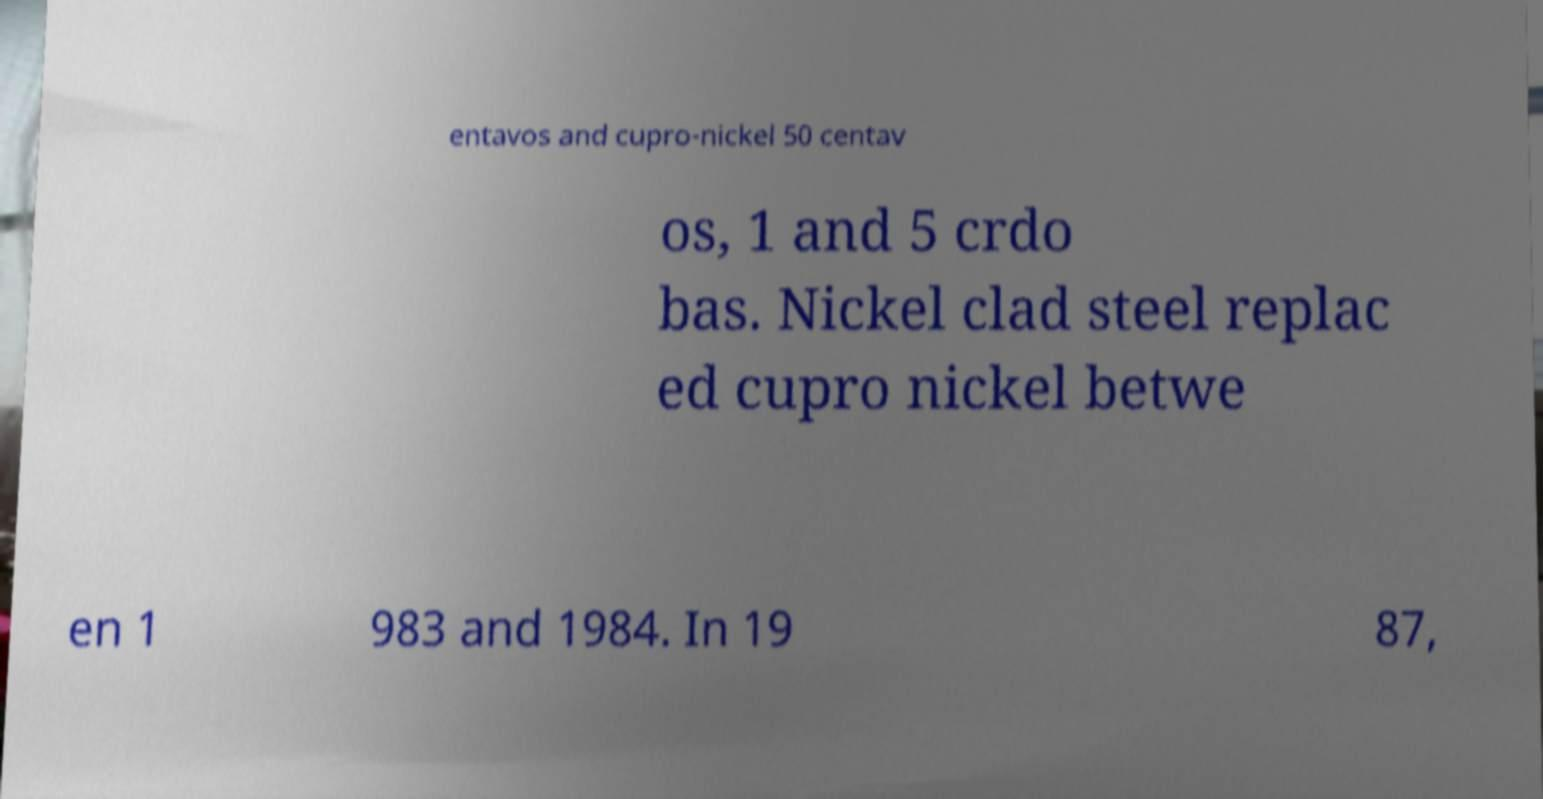Could you extract and type out the text from this image? entavos and cupro-nickel 50 centav os, 1 and 5 crdo bas. Nickel clad steel replac ed cupro nickel betwe en 1 983 and 1984. In 19 87, 